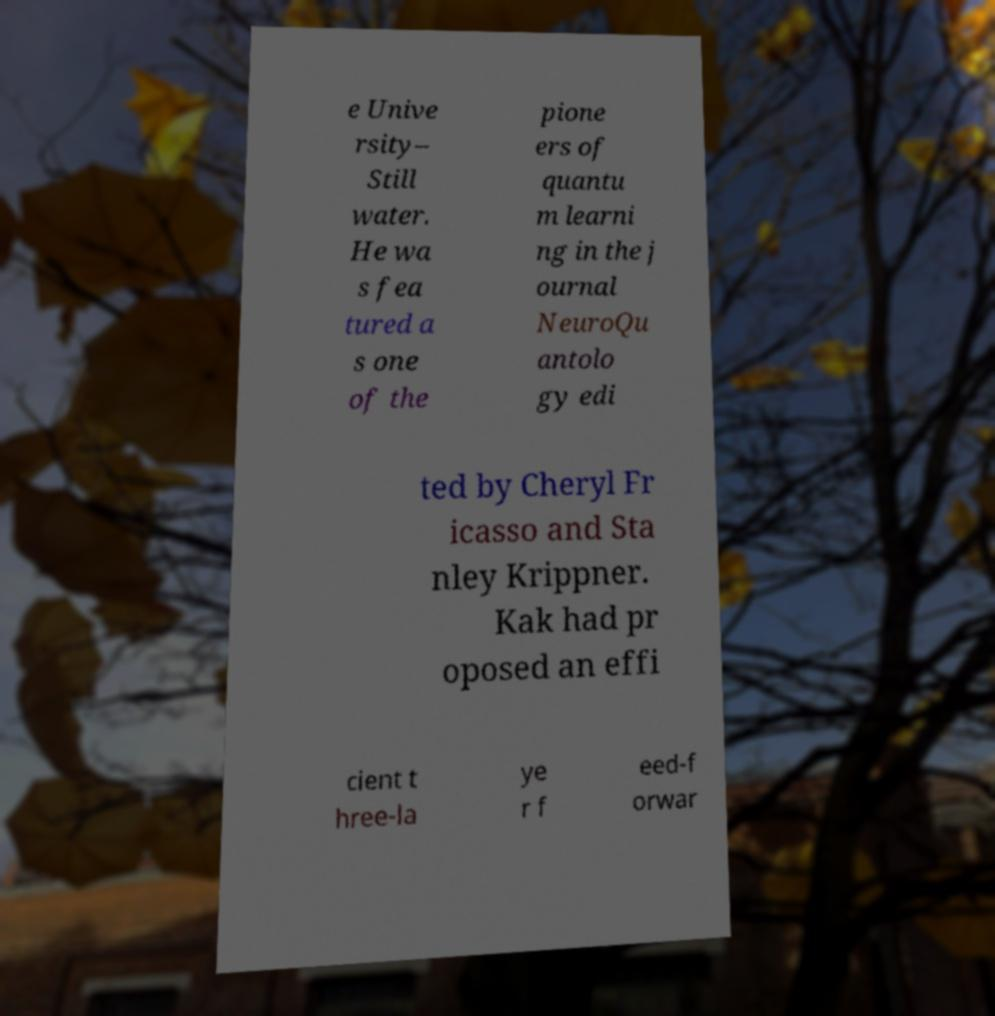What messages or text are displayed in this image? I need them in a readable, typed format. e Unive rsity– Still water. He wa s fea tured a s one of the pione ers of quantu m learni ng in the j ournal NeuroQu antolo gy edi ted by Cheryl Fr icasso and Sta nley Krippner. Kak had pr oposed an effi cient t hree-la ye r f eed-f orwar 